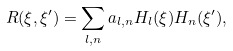<formula> <loc_0><loc_0><loc_500><loc_500>R ( \xi , \xi ^ { \prime } ) = \sum _ { l , n } a _ { l , n } H _ { l } ( \xi ) H _ { n } ( \xi ^ { \prime } ) ,</formula> 